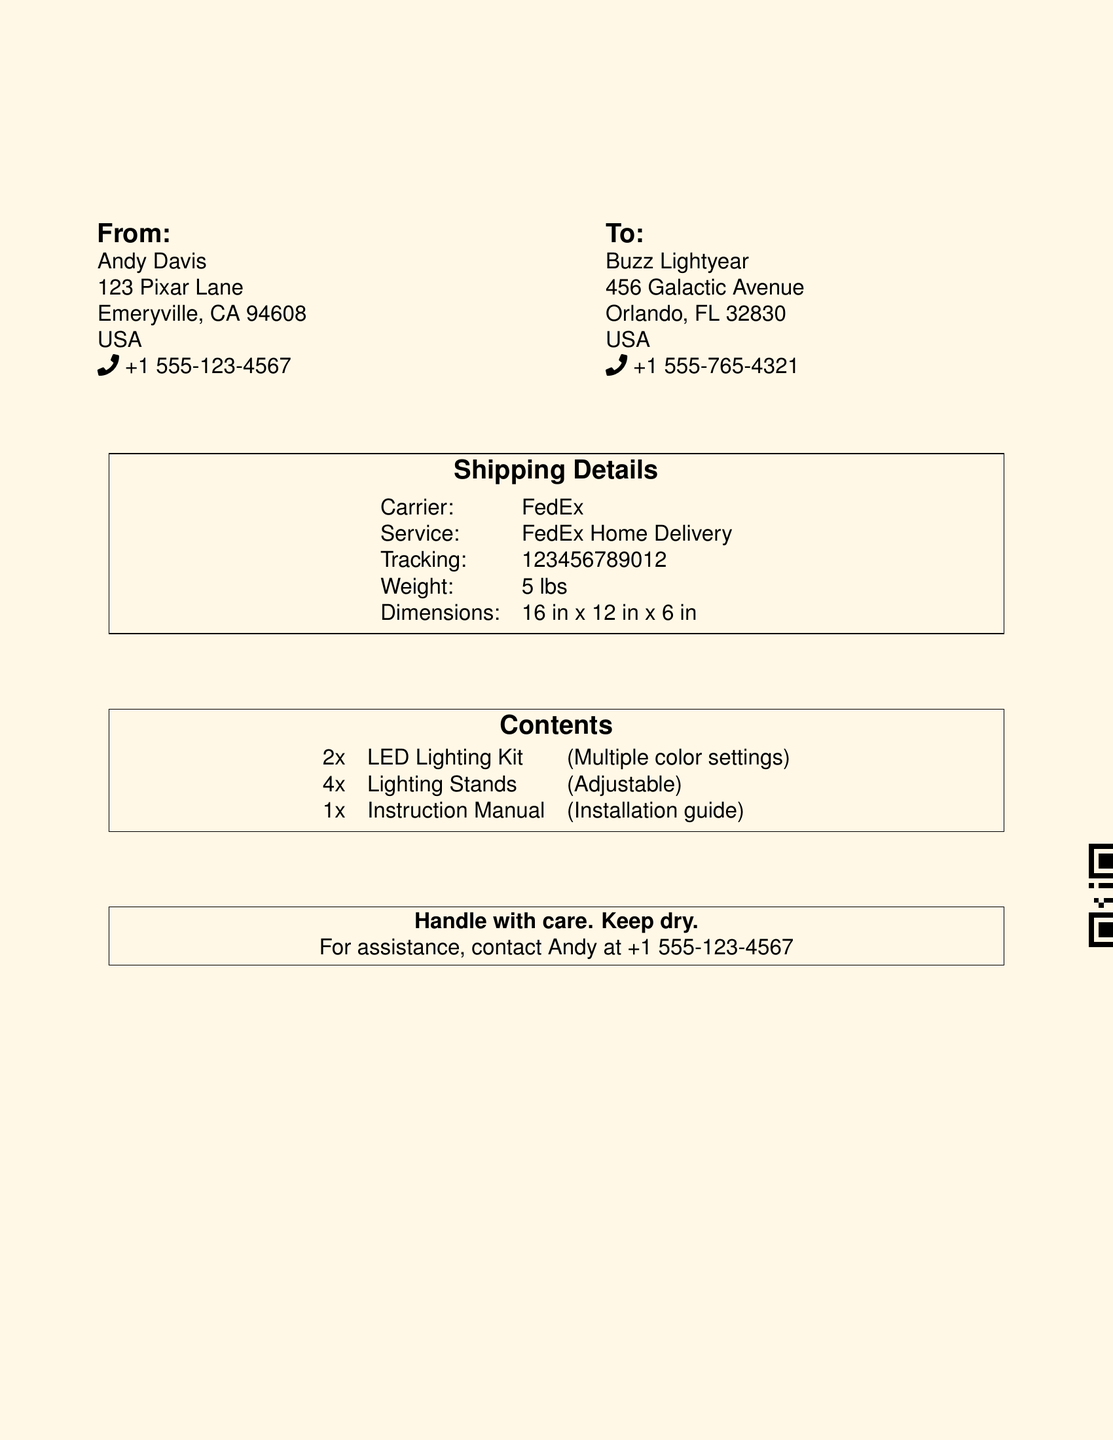What is the sender's name? The sender's name is listed in the 'From' section of the document.
Answer: Andy Davis What is the recipient's address? The recipient's address is found in the 'To' section of the document.
Answer: 456 Galactic Avenue, Orlando, FL 32830, USA What is the tracking number? The tracking number is specified under 'Shipping Details' in the document.
Answer: 123456789012 What items are included in the package? The items are detailed in the 'Contents' section, listing what is inside the parcel.
Answer: 2x LED Lighting Kit, 4x Lighting Stands, 1x Instruction Manual What is the weight of the parcel? The weight is mentioned in the 'Shipping Details' section of the document.
Answer: 5 lbs What should you do if you need assistance? The document contains a note on who to contact for help.
Answer: Contact Andy at +1 555-123-4567 What type of delivery service is used for this shipment? The delivery service is stated in the 'Shipping Details' section of the document.
Answer: FedEx Home Delivery What is the color of the shipping label? The color scheme is evident in the background of the label on the document.
Answer: Toy yellow 